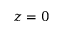<formula> <loc_0><loc_0><loc_500><loc_500>z = 0</formula> 